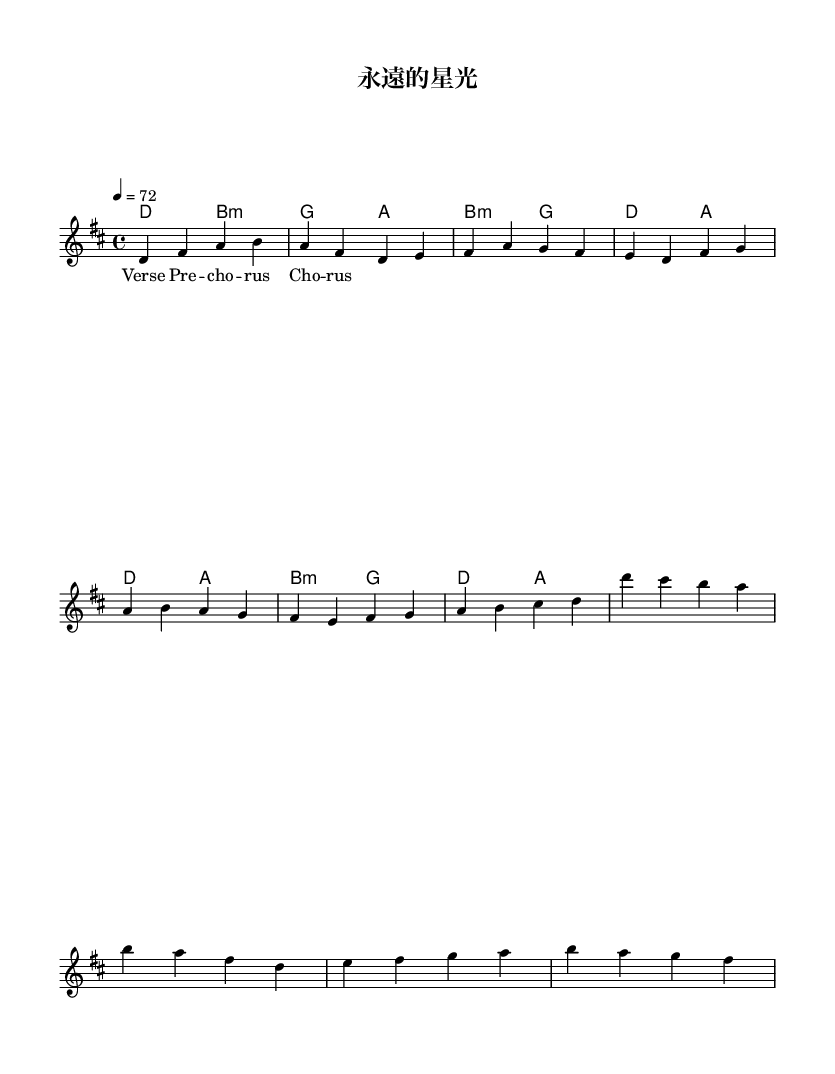what is the key signature of this music? The key signature is D major, which is indicated by the two sharps (F# and C#) marked in the key signature section of the sheet music.
Answer: D major what is the time signature of this music? The time signature of the piece shown is 4/4, which is represented at the beginning of the score and indicates that each measure has four beats.
Answer: 4/4 what is the tempo marking of this music? The tempo marking indicates a speed of 72 beats per minute, which is noted as "4 = 72" at the beginning of the score.
Answer: 72 how many sections are in this composition? The composition consists of three distinct sections: the verse, pre-chorus, and chorus, as indicated in the lyrics part of the sheet music.
Answer: Three which chord is used in the verse section? The chord used in the verse section begins with D major, as seen in the harmonies line where the first chord matches the suggested harmonic progression for the verse.
Answer: D how does the pre-chorus transition from the verse? The pre-chorus transitions smoothly from the verse by following the chord progression that connects B minor and G major, leading into the more intense moments in the lyrics. This can be analyzed by comparing the notes in the melody with the harmonies provided for each section.
Answer: B minor to G major what vocal quality is emphasized in Cantonese rock ballads? The vocal quality emphasized in Cantonese rock ballads typically includes powerful vocals, which express deep emotions that resonate through the melodic lines and rich harmonies seen in the sheet music.
Answer: Powerful 